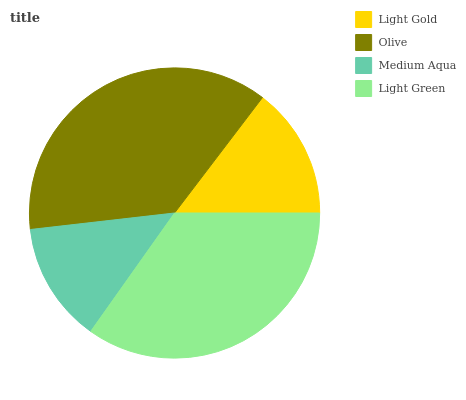Is Medium Aqua the minimum?
Answer yes or no. Yes. Is Olive the maximum?
Answer yes or no. Yes. Is Olive the minimum?
Answer yes or no. No. Is Medium Aqua the maximum?
Answer yes or no. No. Is Olive greater than Medium Aqua?
Answer yes or no. Yes. Is Medium Aqua less than Olive?
Answer yes or no. Yes. Is Medium Aqua greater than Olive?
Answer yes or no. No. Is Olive less than Medium Aqua?
Answer yes or no. No. Is Light Green the high median?
Answer yes or no. Yes. Is Light Gold the low median?
Answer yes or no. Yes. Is Light Gold the high median?
Answer yes or no. No. Is Light Green the low median?
Answer yes or no. No. 